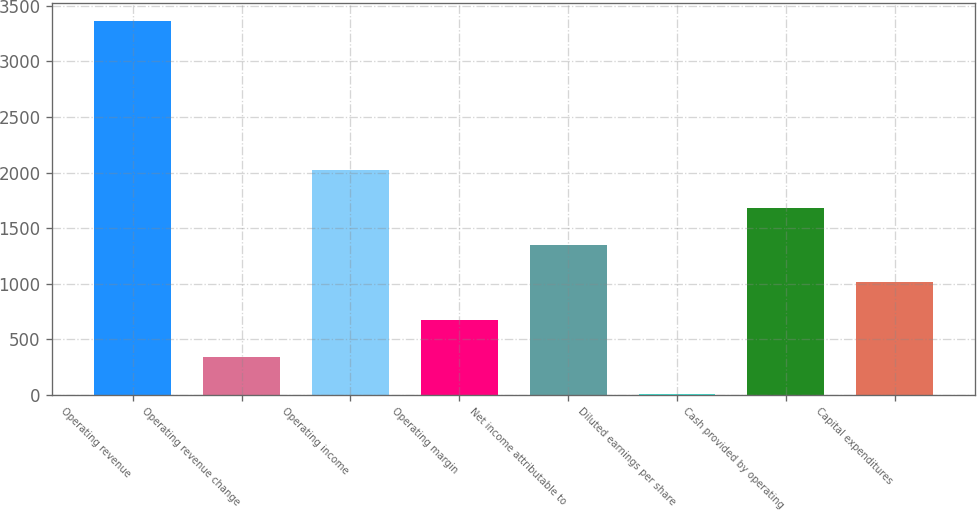Convert chart. <chart><loc_0><loc_0><loc_500><loc_500><bar_chart><fcel>Operating revenue<fcel>Operating revenue change<fcel>Operating income<fcel>Operating margin<fcel>Net income attributable to<fcel>Diluted earnings per share<fcel>Cash provided by operating<fcel>Capital expenditures<nl><fcel>3362.2<fcel>340.57<fcel>2019.27<fcel>676.31<fcel>1347.79<fcel>4.83<fcel>1683.53<fcel>1012.05<nl></chart> 